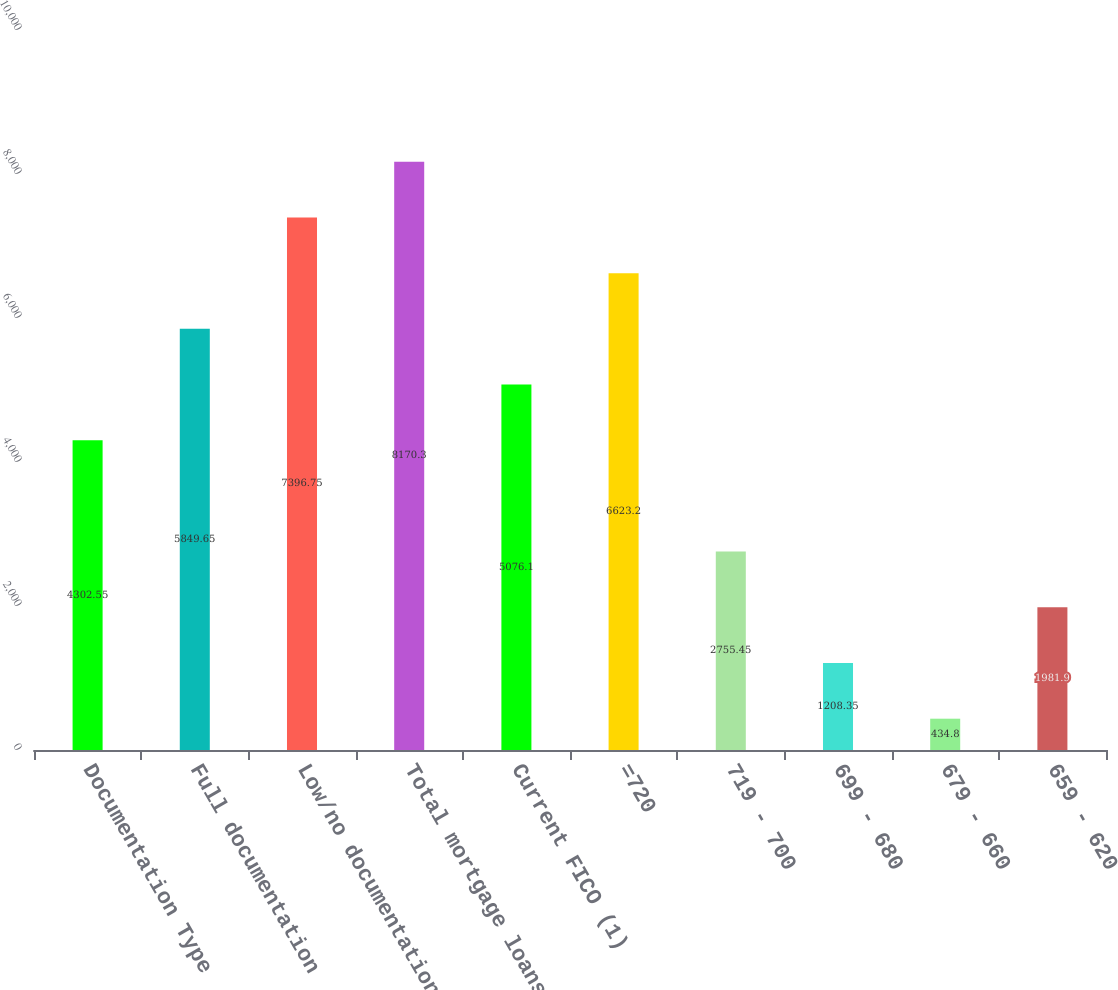<chart> <loc_0><loc_0><loc_500><loc_500><bar_chart><fcel>Documentation Type<fcel>Full documentation<fcel>Low/no documentation<fcel>Total mortgage loans<fcel>Current FICO (1)<fcel>=720<fcel>719 - 700<fcel>699 - 680<fcel>679 - 660<fcel>659 - 620<nl><fcel>4302.55<fcel>5849.65<fcel>7396.75<fcel>8170.3<fcel>5076.1<fcel>6623.2<fcel>2755.45<fcel>1208.35<fcel>434.8<fcel>1981.9<nl></chart> 